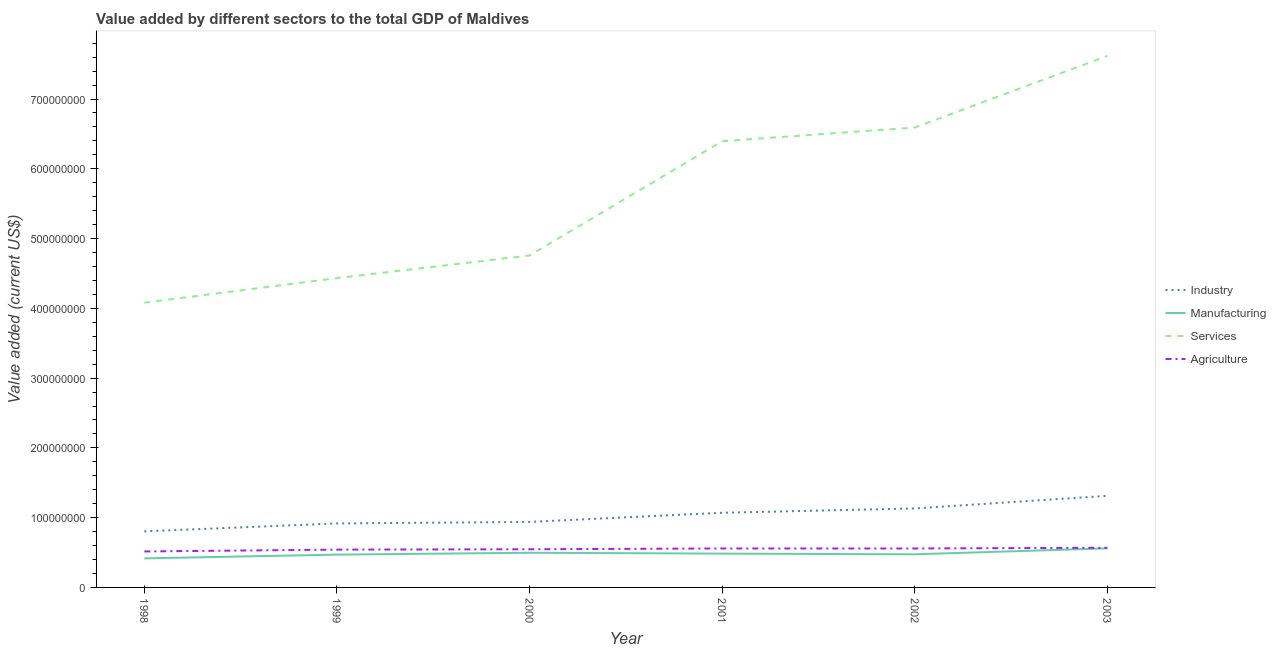Does the line corresponding to value added by agricultural sector intersect with the line corresponding to value added by services sector?
Offer a terse response. No. Is the number of lines equal to the number of legend labels?
Keep it short and to the point. Yes. What is the value added by services sector in 1999?
Keep it short and to the point. 4.43e+08. Across all years, what is the maximum value added by industrial sector?
Your answer should be compact. 1.31e+08. Across all years, what is the minimum value added by services sector?
Your answer should be compact. 4.08e+08. What is the total value added by industrial sector in the graph?
Your answer should be compact. 6.18e+08. What is the difference between the value added by manufacturing sector in 1999 and that in 2000?
Keep it short and to the point. -2.68e+06. What is the difference between the value added by industrial sector in 2001 and the value added by services sector in 1999?
Provide a short and direct response. -3.36e+08. What is the average value added by industrial sector per year?
Provide a short and direct response. 1.03e+08. In the year 2001, what is the difference between the value added by manufacturing sector and value added by agricultural sector?
Give a very brief answer. -7.42e+06. In how many years, is the value added by manufacturing sector greater than 40000000 US$?
Your answer should be compact. 6. What is the ratio of the value added by agricultural sector in 1999 to that in 2003?
Your answer should be very brief. 0.95. Is the difference between the value added by manufacturing sector in 2001 and 2002 greater than the difference between the value added by industrial sector in 2001 and 2002?
Offer a very short reply. Yes. What is the difference between the highest and the second highest value added by agricultural sector?
Your answer should be compact. 9.67e+05. What is the difference between the highest and the lowest value added by manufacturing sector?
Offer a terse response. 1.44e+07. Is it the case that in every year, the sum of the value added by industrial sector and value added by manufacturing sector is greater than the value added by services sector?
Provide a succinct answer. No. Is the value added by services sector strictly greater than the value added by manufacturing sector over the years?
Provide a short and direct response. Yes. Is the value added by agricultural sector strictly less than the value added by manufacturing sector over the years?
Offer a very short reply. No. How many lines are there?
Make the answer very short. 4. How many years are there in the graph?
Provide a succinct answer. 6. What is the difference between two consecutive major ticks on the Y-axis?
Give a very brief answer. 1.00e+08. Are the values on the major ticks of Y-axis written in scientific E-notation?
Provide a succinct answer. No. How are the legend labels stacked?
Offer a very short reply. Vertical. What is the title of the graph?
Give a very brief answer. Value added by different sectors to the total GDP of Maldives. Does "Other expenses" appear as one of the legend labels in the graph?
Make the answer very short. No. What is the label or title of the X-axis?
Provide a short and direct response. Year. What is the label or title of the Y-axis?
Give a very brief answer. Value added (current US$). What is the Value added (current US$) of Industry in 1998?
Provide a short and direct response. 8.04e+07. What is the Value added (current US$) in Manufacturing in 1998?
Your answer should be compact. 4.16e+07. What is the Value added (current US$) of Services in 1998?
Give a very brief answer. 4.08e+08. What is the Value added (current US$) of Agriculture in 1998?
Give a very brief answer. 5.16e+07. What is the Value added (current US$) of Industry in 1999?
Ensure brevity in your answer.  9.17e+07. What is the Value added (current US$) of Manufacturing in 1999?
Keep it short and to the point. 4.70e+07. What is the Value added (current US$) in Services in 1999?
Provide a succinct answer. 4.43e+08. What is the Value added (current US$) in Agriculture in 1999?
Keep it short and to the point. 5.42e+07. What is the Value added (current US$) in Industry in 2000?
Ensure brevity in your answer.  9.39e+07. What is the Value added (current US$) of Manufacturing in 2000?
Provide a short and direct response. 4.97e+07. What is the Value added (current US$) of Services in 2000?
Offer a very short reply. 4.76e+08. What is the Value added (current US$) of Agriculture in 2000?
Your response must be concise. 5.47e+07. What is the Value added (current US$) in Industry in 2001?
Offer a terse response. 1.07e+08. What is the Value added (current US$) of Manufacturing in 2001?
Make the answer very short. 4.84e+07. What is the Value added (current US$) in Services in 2001?
Ensure brevity in your answer.  6.40e+08. What is the Value added (current US$) of Agriculture in 2001?
Provide a short and direct response. 5.59e+07. What is the Value added (current US$) in Industry in 2002?
Keep it short and to the point. 1.13e+08. What is the Value added (current US$) in Manufacturing in 2002?
Offer a terse response. 4.75e+07. What is the Value added (current US$) in Services in 2002?
Give a very brief answer. 6.59e+08. What is the Value added (current US$) of Agriculture in 2002?
Your response must be concise. 5.58e+07. What is the Value added (current US$) of Industry in 2003?
Your answer should be compact. 1.31e+08. What is the Value added (current US$) in Manufacturing in 2003?
Provide a short and direct response. 5.60e+07. What is the Value added (current US$) of Services in 2003?
Give a very brief answer. 7.62e+08. What is the Value added (current US$) of Agriculture in 2003?
Keep it short and to the point. 5.68e+07. Across all years, what is the maximum Value added (current US$) in Industry?
Ensure brevity in your answer.  1.31e+08. Across all years, what is the maximum Value added (current US$) in Manufacturing?
Keep it short and to the point. 5.60e+07. Across all years, what is the maximum Value added (current US$) of Services?
Provide a short and direct response. 7.62e+08. Across all years, what is the maximum Value added (current US$) in Agriculture?
Keep it short and to the point. 5.68e+07. Across all years, what is the minimum Value added (current US$) of Industry?
Ensure brevity in your answer.  8.04e+07. Across all years, what is the minimum Value added (current US$) in Manufacturing?
Your answer should be very brief. 4.16e+07. Across all years, what is the minimum Value added (current US$) in Services?
Your response must be concise. 4.08e+08. Across all years, what is the minimum Value added (current US$) of Agriculture?
Ensure brevity in your answer.  5.16e+07. What is the total Value added (current US$) in Industry in the graph?
Keep it short and to the point. 6.18e+08. What is the total Value added (current US$) in Manufacturing in the graph?
Your answer should be compact. 2.90e+08. What is the total Value added (current US$) in Services in the graph?
Make the answer very short. 3.39e+09. What is the total Value added (current US$) of Agriculture in the graph?
Give a very brief answer. 3.29e+08. What is the difference between the Value added (current US$) of Industry in 1998 and that in 1999?
Your response must be concise. -1.13e+07. What is the difference between the Value added (current US$) in Manufacturing in 1998 and that in 1999?
Provide a short and direct response. -5.39e+06. What is the difference between the Value added (current US$) of Services in 1998 and that in 1999?
Keep it short and to the point. -3.52e+07. What is the difference between the Value added (current US$) in Agriculture in 1998 and that in 1999?
Your answer should be very brief. -2.61e+06. What is the difference between the Value added (current US$) in Industry in 1998 and that in 2000?
Your answer should be compact. -1.35e+07. What is the difference between the Value added (current US$) of Manufacturing in 1998 and that in 2000?
Provide a short and direct response. -8.07e+06. What is the difference between the Value added (current US$) of Services in 1998 and that in 2000?
Keep it short and to the point. -6.76e+07. What is the difference between the Value added (current US$) in Agriculture in 1998 and that in 2000?
Your answer should be very brief. -3.13e+06. What is the difference between the Value added (current US$) of Industry in 1998 and that in 2001?
Give a very brief answer. -2.66e+07. What is the difference between the Value added (current US$) in Manufacturing in 1998 and that in 2001?
Give a very brief answer. -6.81e+06. What is the difference between the Value added (current US$) of Services in 1998 and that in 2001?
Your answer should be very brief. -2.31e+08. What is the difference between the Value added (current US$) in Agriculture in 1998 and that in 2001?
Ensure brevity in your answer.  -4.29e+06. What is the difference between the Value added (current US$) of Industry in 1998 and that in 2002?
Your response must be concise. -3.28e+07. What is the difference between the Value added (current US$) in Manufacturing in 1998 and that in 2002?
Your response must be concise. -5.86e+06. What is the difference between the Value added (current US$) of Services in 1998 and that in 2002?
Give a very brief answer. -2.51e+08. What is the difference between the Value added (current US$) of Agriculture in 1998 and that in 2002?
Your answer should be very brief. -4.26e+06. What is the difference between the Value added (current US$) in Industry in 1998 and that in 2003?
Offer a terse response. -5.09e+07. What is the difference between the Value added (current US$) in Manufacturing in 1998 and that in 2003?
Give a very brief answer. -1.44e+07. What is the difference between the Value added (current US$) of Services in 1998 and that in 2003?
Give a very brief answer. -3.54e+08. What is the difference between the Value added (current US$) in Agriculture in 1998 and that in 2003?
Ensure brevity in your answer.  -5.26e+06. What is the difference between the Value added (current US$) in Industry in 1999 and that in 2000?
Make the answer very short. -2.16e+06. What is the difference between the Value added (current US$) in Manufacturing in 1999 and that in 2000?
Provide a succinct answer. -2.68e+06. What is the difference between the Value added (current US$) of Services in 1999 and that in 2000?
Your answer should be very brief. -3.24e+07. What is the difference between the Value added (current US$) of Agriculture in 1999 and that in 2000?
Provide a succinct answer. -5.16e+05. What is the difference between the Value added (current US$) of Industry in 1999 and that in 2001?
Offer a terse response. -1.53e+07. What is the difference between the Value added (current US$) of Manufacturing in 1999 and that in 2001?
Your answer should be compact. -1.42e+06. What is the difference between the Value added (current US$) in Services in 1999 and that in 2001?
Keep it short and to the point. -1.96e+08. What is the difference between the Value added (current US$) of Agriculture in 1999 and that in 2001?
Provide a short and direct response. -1.68e+06. What is the difference between the Value added (current US$) in Industry in 1999 and that in 2002?
Your answer should be very brief. -2.15e+07. What is the difference between the Value added (current US$) in Manufacturing in 1999 and that in 2002?
Make the answer very short. -4.71e+05. What is the difference between the Value added (current US$) of Services in 1999 and that in 2002?
Your response must be concise. -2.16e+08. What is the difference between the Value added (current US$) of Agriculture in 1999 and that in 2002?
Provide a succinct answer. -1.65e+06. What is the difference between the Value added (current US$) of Industry in 1999 and that in 2003?
Your answer should be compact. -3.96e+07. What is the difference between the Value added (current US$) of Manufacturing in 1999 and that in 2003?
Your answer should be compact. -8.97e+06. What is the difference between the Value added (current US$) of Services in 1999 and that in 2003?
Give a very brief answer. -3.18e+08. What is the difference between the Value added (current US$) in Agriculture in 1999 and that in 2003?
Keep it short and to the point. -2.65e+06. What is the difference between the Value added (current US$) in Industry in 2000 and that in 2001?
Provide a succinct answer. -1.31e+07. What is the difference between the Value added (current US$) of Manufacturing in 2000 and that in 2001?
Keep it short and to the point. 1.26e+06. What is the difference between the Value added (current US$) in Services in 2000 and that in 2001?
Make the answer very short. -1.64e+08. What is the difference between the Value added (current US$) in Agriculture in 2000 and that in 2001?
Offer a very short reply. -1.16e+06. What is the difference between the Value added (current US$) in Industry in 2000 and that in 2002?
Give a very brief answer. -1.93e+07. What is the difference between the Value added (current US$) of Manufacturing in 2000 and that in 2002?
Make the answer very short. 2.21e+06. What is the difference between the Value added (current US$) of Services in 2000 and that in 2002?
Make the answer very short. -1.83e+08. What is the difference between the Value added (current US$) in Agriculture in 2000 and that in 2002?
Your answer should be compact. -1.14e+06. What is the difference between the Value added (current US$) in Industry in 2000 and that in 2003?
Offer a terse response. -3.74e+07. What is the difference between the Value added (current US$) of Manufacturing in 2000 and that in 2003?
Your answer should be compact. -6.29e+06. What is the difference between the Value added (current US$) of Services in 2000 and that in 2003?
Provide a short and direct response. -2.86e+08. What is the difference between the Value added (current US$) of Agriculture in 2000 and that in 2003?
Offer a very short reply. -2.13e+06. What is the difference between the Value added (current US$) of Industry in 2001 and that in 2002?
Your answer should be very brief. -6.17e+06. What is the difference between the Value added (current US$) of Manufacturing in 2001 and that in 2002?
Provide a short and direct response. 9.48e+05. What is the difference between the Value added (current US$) of Services in 2001 and that in 2002?
Keep it short and to the point. -1.97e+07. What is the difference between the Value added (current US$) in Agriculture in 2001 and that in 2002?
Ensure brevity in your answer.  2.72e+04. What is the difference between the Value added (current US$) in Industry in 2001 and that in 2003?
Provide a succinct answer. -2.43e+07. What is the difference between the Value added (current US$) of Manufacturing in 2001 and that in 2003?
Your response must be concise. -7.55e+06. What is the difference between the Value added (current US$) in Services in 2001 and that in 2003?
Ensure brevity in your answer.  -1.22e+08. What is the difference between the Value added (current US$) in Agriculture in 2001 and that in 2003?
Keep it short and to the point. -9.67e+05. What is the difference between the Value added (current US$) in Industry in 2002 and that in 2003?
Offer a very short reply. -1.81e+07. What is the difference between the Value added (current US$) in Manufacturing in 2002 and that in 2003?
Your response must be concise. -8.50e+06. What is the difference between the Value added (current US$) in Services in 2002 and that in 2003?
Provide a short and direct response. -1.03e+08. What is the difference between the Value added (current US$) in Agriculture in 2002 and that in 2003?
Ensure brevity in your answer.  -9.95e+05. What is the difference between the Value added (current US$) of Industry in 1998 and the Value added (current US$) of Manufacturing in 1999?
Keep it short and to the point. 3.34e+07. What is the difference between the Value added (current US$) in Industry in 1998 and the Value added (current US$) in Services in 1999?
Make the answer very short. -3.63e+08. What is the difference between the Value added (current US$) of Industry in 1998 and the Value added (current US$) of Agriculture in 1999?
Keep it short and to the point. 2.62e+07. What is the difference between the Value added (current US$) in Manufacturing in 1998 and the Value added (current US$) in Services in 1999?
Offer a terse response. -4.02e+08. What is the difference between the Value added (current US$) in Manufacturing in 1998 and the Value added (current US$) in Agriculture in 1999?
Keep it short and to the point. -1.25e+07. What is the difference between the Value added (current US$) in Services in 1998 and the Value added (current US$) in Agriculture in 1999?
Keep it short and to the point. 3.54e+08. What is the difference between the Value added (current US$) in Industry in 1998 and the Value added (current US$) in Manufacturing in 2000?
Keep it short and to the point. 3.07e+07. What is the difference between the Value added (current US$) in Industry in 1998 and the Value added (current US$) in Services in 2000?
Make the answer very short. -3.95e+08. What is the difference between the Value added (current US$) in Industry in 1998 and the Value added (current US$) in Agriculture in 2000?
Your answer should be compact. 2.57e+07. What is the difference between the Value added (current US$) in Manufacturing in 1998 and the Value added (current US$) in Services in 2000?
Your answer should be very brief. -4.34e+08. What is the difference between the Value added (current US$) in Manufacturing in 1998 and the Value added (current US$) in Agriculture in 2000?
Your answer should be very brief. -1.31e+07. What is the difference between the Value added (current US$) of Services in 1998 and the Value added (current US$) of Agriculture in 2000?
Provide a succinct answer. 3.53e+08. What is the difference between the Value added (current US$) in Industry in 1998 and the Value added (current US$) in Manufacturing in 2001?
Make the answer very short. 3.19e+07. What is the difference between the Value added (current US$) of Industry in 1998 and the Value added (current US$) of Services in 2001?
Keep it short and to the point. -5.59e+08. What is the difference between the Value added (current US$) of Industry in 1998 and the Value added (current US$) of Agriculture in 2001?
Provide a short and direct response. 2.45e+07. What is the difference between the Value added (current US$) in Manufacturing in 1998 and the Value added (current US$) in Services in 2001?
Offer a terse response. -5.98e+08. What is the difference between the Value added (current US$) of Manufacturing in 1998 and the Value added (current US$) of Agriculture in 2001?
Provide a short and direct response. -1.42e+07. What is the difference between the Value added (current US$) of Services in 1998 and the Value added (current US$) of Agriculture in 2001?
Ensure brevity in your answer.  3.52e+08. What is the difference between the Value added (current US$) of Industry in 1998 and the Value added (current US$) of Manufacturing in 2002?
Your answer should be compact. 3.29e+07. What is the difference between the Value added (current US$) of Industry in 1998 and the Value added (current US$) of Services in 2002?
Make the answer very short. -5.79e+08. What is the difference between the Value added (current US$) of Industry in 1998 and the Value added (current US$) of Agriculture in 2002?
Ensure brevity in your answer.  2.46e+07. What is the difference between the Value added (current US$) in Manufacturing in 1998 and the Value added (current US$) in Services in 2002?
Ensure brevity in your answer.  -6.18e+08. What is the difference between the Value added (current US$) in Manufacturing in 1998 and the Value added (current US$) in Agriculture in 2002?
Offer a terse response. -1.42e+07. What is the difference between the Value added (current US$) in Services in 1998 and the Value added (current US$) in Agriculture in 2002?
Offer a terse response. 3.52e+08. What is the difference between the Value added (current US$) in Industry in 1998 and the Value added (current US$) in Manufacturing in 2003?
Provide a short and direct response. 2.44e+07. What is the difference between the Value added (current US$) in Industry in 1998 and the Value added (current US$) in Services in 2003?
Provide a short and direct response. -6.81e+08. What is the difference between the Value added (current US$) of Industry in 1998 and the Value added (current US$) of Agriculture in 2003?
Your answer should be very brief. 2.36e+07. What is the difference between the Value added (current US$) of Manufacturing in 1998 and the Value added (current US$) of Services in 2003?
Make the answer very short. -7.20e+08. What is the difference between the Value added (current US$) in Manufacturing in 1998 and the Value added (current US$) in Agriculture in 2003?
Provide a short and direct response. -1.52e+07. What is the difference between the Value added (current US$) in Services in 1998 and the Value added (current US$) in Agriculture in 2003?
Provide a short and direct response. 3.51e+08. What is the difference between the Value added (current US$) of Industry in 1999 and the Value added (current US$) of Manufacturing in 2000?
Offer a terse response. 4.20e+07. What is the difference between the Value added (current US$) in Industry in 1999 and the Value added (current US$) in Services in 2000?
Offer a very short reply. -3.84e+08. What is the difference between the Value added (current US$) of Industry in 1999 and the Value added (current US$) of Agriculture in 2000?
Your answer should be very brief. 3.70e+07. What is the difference between the Value added (current US$) of Manufacturing in 1999 and the Value added (current US$) of Services in 2000?
Your answer should be very brief. -4.29e+08. What is the difference between the Value added (current US$) in Manufacturing in 1999 and the Value added (current US$) in Agriculture in 2000?
Make the answer very short. -7.68e+06. What is the difference between the Value added (current US$) in Services in 1999 and the Value added (current US$) in Agriculture in 2000?
Keep it short and to the point. 3.89e+08. What is the difference between the Value added (current US$) of Industry in 1999 and the Value added (current US$) of Manufacturing in 2001?
Your answer should be compact. 4.33e+07. What is the difference between the Value added (current US$) of Industry in 1999 and the Value added (current US$) of Services in 2001?
Your answer should be very brief. -5.48e+08. What is the difference between the Value added (current US$) of Industry in 1999 and the Value added (current US$) of Agriculture in 2001?
Your answer should be compact. 3.59e+07. What is the difference between the Value added (current US$) in Manufacturing in 1999 and the Value added (current US$) in Services in 2001?
Offer a terse response. -5.93e+08. What is the difference between the Value added (current US$) of Manufacturing in 1999 and the Value added (current US$) of Agriculture in 2001?
Your response must be concise. -8.84e+06. What is the difference between the Value added (current US$) in Services in 1999 and the Value added (current US$) in Agriculture in 2001?
Ensure brevity in your answer.  3.87e+08. What is the difference between the Value added (current US$) in Industry in 1999 and the Value added (current US$) in Manufacturing in 2002?
Offer a very short reply. 4.42e+07. What is the difference between the Value added (current US$) in Industry in 1999 and the Value added (current US$) in Services in 2002?
Your answer should be compact. -5.67e+08. What is the difference between the Value added (current US$) of Industry in 1999 and the Value added (current US$) of Agriculture in 2002?
Give a very brief answer. 3.59e+07. What is the difference between the Value added (current US$) in Manufacturing in 1999 and the Value added (current US$) in Services in 2002?
Your response must be concise. -6.12e+08. What is the difference between the Value added (current US$) of Manufacturing in 1999 and the Value added (current US$) of Agriculture in 2002?
Provide a succinct answer. -8.81e+06. What is the difference between the Value added (current US$) of Services in 1999 and the Value added (current US$) of Agriculture in 2002?
Provide a short and direct response. 3.88e+08. What is the difference between the Value added (current US$) of Industry in 1999 and the Value added (current US$) of Manufacturing in 2003?
Provide a succinct answer. 3.57e+07. What is the difference between the Value added (current US$) in Industry in 1999 and the Value added (current US$) in Services in 2003?
Your answer should be very brief. -6.70e+08. What is the difference between the Value added (current US$) of Industry in 1999 and the Value added (current US$) of Agriculture in 2003?
Provide a short and direct response. 3.49e+07. What is the difference between the Value added (current US$) in Manufacturing in 1999 and the Value added (current US$) in Services in 2003?
Provide a short and direct response. -7.15e+08. What is the difference between the Value added (current US$) in Manufacturing in 1999 and the Value added (current US$) in Agriculture in 2003?
Your answer should be very brief. -9.81e+06. What is the difference between the Value added (current US$) of Services in 1999 and the Value added (current US$) of Agriculture in 2003?
Offer a very short reply. 3.87e+08. What is the difference between the Value added (current US$) of Industry in 2000 and the Value added (current US$) of Manufacturing in 2001?
Your response must be concise. 4.54e+07. What is the difference between the Value added (current US$) of Industry in 2000 and the Value added (current US$) of Services in 2001?
Offer a terse response. -5.46e+08. What is the difference between the Value added (current US$) of Industry in 2000 and the Value added (current US$) of Agriculture in 2001?
Offer a very short reply. 3.80e+07. What is the difference between the Value added (current US$) of Manufacturing in 2000 and the Value added (current US$) of Services in 2001?
Ensure brevity in your answer.  -5.90e+08. What is the difference between the Value added (current US$) in Manufacturing in 2000 and the Value added (current US$) in Agriculture in 2001?
Offer a very short reply. -6.16e+06. What is the difference between the Value added (current US$) of Services in 2000 and the Value added (current US$) of Agriculture in 2001?
Offer a terse response. 4.20e+08. What is the difference between the Value added (current US$) of Industry in 2000 and the Value added (current US$) of Manufacturing in 2002?
Provide a succinct answer. 4.64e+07. What is the difference between the Value added (current US$) in Industry in 2000 and the Value added (current US$) in Services in 2002?
Your response must be concise. -5.65e+08. What is the difference between the Value added (current US$) of Industry in 2000 and the Value added (current US$) of Agriculture in 2002?
Ensure brevity in your answer.  3.80e+07. What is the difference between the Value added (current US$) in Manufacturing in 2000 and the Value added (current US$) in Services in 2002?
Give a very brief answer. -6.10e+08. What is the difference between the Value added (current US$) of Manufacturing in 2000 and the Value added (current US$) of Agriculture in 2002?
Your answer should be very brief. -6.13e+06. What is the difference between the Value added (current US$) in Services in 2000 and the Value added (current US$) in Agriculture in 2002?
Your answer should be compact. 4.20e+08. What is the difference between the Value added (current US$) in Industry in 2000 and the Value added (current US$) in Manufacturing in 2003?
Make the answer very short. 3.79e+07. What is the difference between the Value added (current US$) of Industry in 2000 and the Value added (current US$) of Services in 2003?
Your answer should be compact. -6.68e+08. What is the difference between the Value added (current US$) of Industry in 2000 and the Value added (current US$) of Agriculture in 2003?
Provide a short and direct response. 3.71e+07. What is the difference between the Value added (current US$) of Manufacturing in 2000 and the Value added (current US$) of Services in 2003?
Give a very brief answer. -7.12e+08. What is the difference between the Value added (current US$) in Manufacturing in 2000 and the Value added (current US$) in Agriculture in 2003?
Your answer should be very brief. -7.13e+06. What is the difference between the Value added (current US$) of Services in 2000 and the Value added (current US$) of Agriculture in 2003?
Your answer should be compact. 4.19e+08. What is the difference between the Value added (current US$) of Industry in 2001 and the Value added (current US$) of Manufacturing in 2002?
Offer a very short reply. 5.95e+07. What is the difference between the Value added (current US$) in Industry in 2001 and the Value added (current US$) in Services in 2002?
Keep it short and to the point. -5.52e+08. What is the difference between the Value added (current US$) in Industry in 2001 and the Value added (current US$) in Agriculture in 2002?
Offer a terse response. 5.12e+07. What is the difference between the Value added (current US$) of Manufacturing in 2001 and the Value added (current US$) of Services in 2002?
Make the answer very short. -6.11e+08. What is the difference between the Value added (current US$) of Manufacturing in 2001 and the Value added (current US$) of Agriculture in 2002?
Offer a terse response. -7.39e+06. What is the difference between the Value added (current US$) of Services in 2001 and the Value added (current US$) of Agriculture in 2002?
Your answer should be compact. 5.84e+08. What is the difference between the Value added (current US$) in Industry in 2001 and the Value added (current US$) in Manufacturing in 2003?
Your answer should be compact. 5.10e+07. What is the difference between the Value added (current US$) in Industry in 2001 and the Value added (current US$) in Services in 2003?
Your response must be concise. -6.55e+08. What is the difference between the Value added (current US$) in Industry in 2001 and the Value added (current US$) in Agriculture in 2003?
Your answer should be very brief. 5.02e+07. What is the difference between the Value added (current US$) of Manufacturing in 2001 and the Value added (current US$) of Services in 2003?
Provide a short and direct response. -7.13e+08. What is the difference between the Value added (current US$) in Manufacturing in 2001 and the Value added (current US$) in Agriculture in 2003?
Your answer should be very brief. -8.39e+06. What is the difference between the Value added (current US$) of Services in 2001 and the Value added (current US$) of Agriculture in 2003?
Provide a succinct answer. 5.83e+08. What is the difference between the Value added (current US$) in Industry in 2002 and the Value added (current US$) in Manufacturing in 2003?
Ensure brevity in your answer.  5.72e+07. What is the difference between the Value added (current US$) in Industry in 2002 and the Value added (current US$) in Services in 2003?
Your response must be concise. -6.49e+08. What is the difference between the Value added (current US$) of Industry in 2002 and the Value added (current US$) of Agriculture in 2003?
Provide a succinct answer. 5.64e+07. What is the difference between the Value added (current US$) of Manufacturing in 2002 and the Value added (current US$) of Services in 2003?
Your answer should be compact. -7.14e+08. What is the difference between the Value added (current US$) in Manufacturing in 2002 and the Value added (current US$) in Agriculture in 2003?
Offer a very short reply. -9.34e+06. What is the difference between the Value added (current US$) in Services in 2002 and the Value added (current US$) in Agriculture in 2003?
Your answer should be very brief. 6.02e+08. What is the average Value added (current US$) of Industry per year?
Make the answer very short. 1.03e+08. What is the average Value added (current US$) in Manufacturing per year?
Provide a succinct answer. 4.84e+07. What is the average Value added (current US$) of Services per year?
Provide a short and direct response. 5.65e+08. What is the average Value added (current US$) in Agriculture per year?
Your answer should be very brief. 5.48e+07. In the year 1998, what is the difference between the Value added (current US$) in Industry and Value added (current US$) in Manufacturing?
Provide a short and direct response. 3.88e+07. In the year 1998, what is the difference between the Value added (current US$) in Industry and Value added (current US$) in Services?
Offer a terse response. -3.28e+08. In the year 1998, what is the difference between the Value added (current US$) of Industry and Value added (current US$) of Agriculture?
Your answer should be compact. 2.88e+07. In the year 1998, what is the difference between the Value added (current US$) of Manufacturing and Value added (current US$) of Services?
Make the answer very short. -3.67e+08. In the year 1998, what is the difference between the Value added (current US$) in Manufacturing and Value added (current US$) in Agriculture?
Offer a very short reply. -9.94e+06. In the year 1998, what is the difference between the Value added (current US$) in Services and Value added (current US$) in Agriculture?
Your answer should be very brief. 3.57e+08. In the year 1999, what is the difference between the Value added (current US$) in Industry and Value added (current US$) in Manufacturing?
Ensure brevity in your answer.  4.47e+07. In the year 1999, what is the difference between the Value added (current US$) of Industry and Value added (current US$) of Services?
Provide a succinct answer. -3.52e+08. In the year 1999, what is the difference between the Value added (current US$) of Industry and Value added (current US$) of Agriculture?
Your answer should be very brief. 3.75e+07. In the year 1999, what is the difference between the Value added (current US$) of Manufacturing and Value added (current US$) of Services?
Ensure brevity in your answer.  -3.96e+08. In the year 1999, what is the difference between the Value added (current US$) of Manufacturing and Value added (current US$) of Agriculture?
Keep it short and to the point. -7.16e+06. In the year 1999, what is the difference between the Value added (current US$) in Services and Value added (current US$) in Agriculture?
Ensure brevity in your answer.  3.89e+08. In the year 2000, what is the difference between the Value added (current US$) of Industry and Value added (current US$) of Manufacturing?
Make the answer very short. 4.42e+07. In the year 2000, what is the difference between the Value added (current US$) in Industry and Value added (current US$) in Services?
Provide a short and direct response. -3.82e+08. In the year 2000, what is the difference between the Value added (current US$) in Industry and Value added (current US$) in Agriculture?
Offer a terse response. 3.92e+07. In the year 2000, what is the difference between the Value added (current US$) in Manufacturing and Value added (current US$) in Services?
Your answer should be compact. -4.26e+08. In the year 2000, what is the difference between the Value added (current US$) in Manufacturing and Value added (current US$) in Agriculture?
Your answer should be compact. -5.00e+06. In the year 2000, what is the difference between the Value added (current US$) of Services and Value added (current US$) of Agriculture?
Your answer should be compact. 4.21e+08. In the year 2001, what is the difference between the Value added (current US$) in Industry and Value added (current US$) in Manufacturing?
Provide a succinct answer. 5.86e+07. In the year 2001, what is the difference between the Value added (current US$) of Industry and Value added (current US$) of Services?
Give a very brief answer. -5.33e+08. In the year 2001, what is the difference between the Value added (current US$) in Industry and Value added (current US$) in Agriculture?
Offer a terse response. 5.12e+07. In the year 2001, what is the difference between the Value added (current US$) of Manufacturing and Value added (current US$) of Services?
Keep it short and to the point. -5.91e+08. In the year 2001, what is the difference between the Value added (current US$) of Manufacturing and Value added (current US$) of Agriculture?
Your answer should be very brief. -7.42e+06. In the year 2001, what is the difference between the Value added (current US$) of Services and Value added (current US$) of Agriculture?
Offer a very short reply. 5.84e+08. In the year 2002, what is the difference between the Value added (current US$) in Industry and Value added (current US$) in Manufacturing?
Your answer should be very brief. 6.57e+07. In the year 2002, what is the difference between the Value added (current US$) in Industry and Value added (current US$) in Services?
Provide a succinct answer. -5.46e+08. In the year 2002, what is the difference between the Value added (current US$) of Industry and Value added (current US$) of Agriculture?
Your answer should be compact. 5.74e+07. In the year 2002, what is the difference between the Value added (current US$) in Manufacturing and Value added (current US$) in Services?
Your answer should be very brief. -6.12e+08. In the year 2002, what is the difference between the Value added (current US$) of Manufacturing and Value added (current US$) of Agriculture?
Provide a short and direct response. -8.34e+06. In the year 2002, what is the difference between the Value added (current US$) of Services and Value added (current US$) of Agriculture?
Provide a short and direct response. 6.03e+08. In the year 2003, what is the difference between the Value added (current US$) of Industry and Value added (current US$) of Manufacturing?
Keep it short and to the point. 7.53e+07. In the year 2003, what is the difference between the Value added (current US$) in Industry and Value added (current US$) in Services?
Give a very brief answer. -6.30e+08. In the year 2003, what is the difference between the Value added (current US$) in Industry and Value added (current US$) in Agriculture?
Ensure brevity in your answer.  7.45e+07. In the year 2003, what is the difference between the Value added (current US$) in Manufacturing and Value added (current US$) in Services?
Give a very brief answer. -7.06e+08. In the year 2003, what is the difference between the Value added (current US$) of Manufacturing and Value added (current US$) of Agriculture?
Your answer should be compact. -8.41e+05. In the year 2003, what is the difference between the Value added (current US$) of Services and Value added (current US$) of Agriculture?
Keep it short and to the point. 7.05e+08. What is the ratio of the Value added (current US$) of Industry in 1998 to that in 1999?
Make the answer very short. 0.88. What is the ratio of the Value added (current US$) of Manufacturing in 1998 to that in 1999?
Ensure brevity in your answer.  0.89. What is the ratio of the Value added (current US$) of Services in 1998 to that in 1999?
Ensure brevity in your answer.  0.92. What is the ratio of the Value added (current US$) of Agriculture in 1998 to that in 1999?
Offer a very short reply. 0.95. What is the ratio of the Value added (current US$) of Industry in 1998 to that in 2000?
Your answer should be very brief. 0.86. What is the ratio of the Value added (current US$) in Manufacturing in 1998 to that in 2000?
Your answer should be compact. 0.84. What is the ratio of the Value added (current US$) of Services in 1998 to that in 2000?
Your answer should be very brief. 0.86. What is the ratio of the Value added (current US$) of Agriculture in 1998 to that in 2000?
Provide a short and direct response. 0.94. What is the ratio of the Value added (current US$) of Industry in 1998 to that in 2001?
Your answer should be compact. 0.75. What is the ratio of the Value added (current US$) in Manufacturing in 1998 to that in 2001?
Your answer should be compact. 0.86. What is the ratio of the Value added (current US$) of Services in 1998 to that in 2001?
Provide a succinct answer. 0.64. What is the ratio of the Value added (current US$) of Agriculture in 1998 to that in 2001?
Your answer should be compact. 0.92. What is the ratio of the Value added (current US$) of Industry in 1998 to that in 2002?
Your response must be concise. 0.71. What is the ratio of the Value added (current US$) of Manufacturing in 1998 to that in 2002?
Your answer should be compact. 0.88. What is the ratio of the Value added (current US$) in Services in 1998 to that in 2002?
Keep it short and to the point. 0.62. What is the ratio of the Value added (current US$) in Agriculture in 1998 to that in 2002?
Offer a very short reply. 0.92. What is the ratio of the Value added (current US$) of Industry in 1998 to that in 2003?
Your response must be concise. 0.61. What is the ratio of the Value added (current US$) of Manufacturing in 1998 to that in 2003?
Ensure brevity in your answer.  0.74. What is the ratio of the Value added (current US$) of Services in 1998 to that in 2003?
Your answer should be very brief. 0.54. What is the ratio of the Value added (current US$) of Agriculture in 1998 to that in 2003?
Offer a very short reply. 0.91. What is the ratio of the Value added (current US$) of Industry in 1999 to that in 2000?
Provide a succinct answer. 0.98. What is the ratio of the Value added (current US$) in Manufacturing in 1999 to that in 2000?
Offer a very short reply. 0.95. What is the ratio of the Value added (current US$) in Services in 1999 to that in 2000?
Ensure brevity in your answer.  0.93. What is the ratio of the Value added (current US$) in Agriculture in 1999 to that in 2000?
Provide a short and direct response. 0.99. What is the ratio of the Value added (current US$) in Industry in 1999 to that in 2001?
Provide a succinct answer. 0.86. What is the ratio of the Value added (current US$) of Manufacturing in 1999 to that in 2001?
Keep it short and to the point. 0.97. What is the ratio of the Value added (current US$) of Services in 1999 to that in 2001?
Make the answer very short. 0.69. What is the ratio of the Value added (current US$) in Agriculture in 1999 to that in 2001?
Ensure brevity in your answer.  0.97. What is the ratio of the Value added (current US$) of Industry in 1999 to that in 2002?
Your answer should be compact. 0.81. What is the ratio of the Value added (current US$) in Services in 1999 to that in 2002?
Provide a short and direct response. 0.67. What is the ratio of the Value added (current US$) of Agriculture in 1999 to that in 2002?
Make the answer very short. 0.97. What is the ratio of the Value added (current US$) in Industry in 1999 to that in 2003?
Offer a very short reply. 0.7. What is the ratio of the Value added (current US$) in Manufacturing in 1999 to that in 2003?
Your response must be concise. 0.84. What is the ratio of the Value added (current US$) in Services in 1999 to that in 2003?
Give a very brief answer. 0.58. What is the ratio of the Value added (current US$) of Agriculture in 1999 to that in 2003?
Offer a very short reply. 0.95. What is the ratio of the Value added (current US$) of Industry in 2000 to that in 2001?
Provide a short and direct response. 0.88. What is the ratio of the Value added (current US$) in Services in 2000 to that in 2001?
Your answer should be very brief. 0.74. What is the ratio of the Value added (current US$) in Agriculture in 2000 to that in 2001?
Provide a succinct answer. 0.98. What is the ratio of the Value added (current US$) in Industry in 2000 to that in 2002?
Offer a very short reply. 0.83. What is the ratio of the Value added (current US$) of Manufacturing in 2000 to that in 2002?
Keep it short and to the point. 1.05. What is the ratio of the Value added (current US$) of Services in 2000 to that in 2002?
Offer a terse response. 0.72. What is the ratio of the Value added (current US$) in Agriculture in 2000 to that in 2002?
Ensure brevity in your answer.  0.98. What is the ratio of the Value added (current US$) of Industry in 2000 to that in 2003?
Your response must be concise. 0.71. What is the ratio of the Value added (current US$) of Manufacturing in 2000 to that in 2003?
Provide a short and direct response. 0.89. What is the ratio of the Value added (current US$) in Services in 2000 to that in 2003?
Offer a terse response. 0.62. What is the ratio of the Value added (current US$) of Agriculture in 2000 to that in 2003?
Keep it short and to the point. 0.96. What is the ratio of the Value added (current US$) of Industry in 2001 to that in 2002?
Make the answer very short. 0.95. What is the ratio of the Value added (current US$) of Services in 2001 to that in 2002?
Offer a terse response. 0.97. What is the ratio of the Value added (current US$) in Industry in 2001 to that in 2003?
Your answer should be compact. 0.82. What is the ratio of the Value added (current US$) of Manufacturing in 2001 to that in 2003?
Your answer should be very brief. 0.87. What is the ratio of the Value added (current US$) in Services in 2001 to that in 2003?
Offer a very short reply. 0.84. What is the ratio of the Value added (current US$) in Agriculture in 2001 to that in 2003?
Give a very brief answer. 0.98. What is the ratio of the Value added (current US$) in Industry in 2002 to that in 2003?
Your answer should be compact. 0.86. What is the ratio of the Value added (current US$) in Manufacturing in 2002 to that in 2003?
Offer a terse response. 0.85. What is the ratio of the Value added (current US$) of Services in 2002 to that in 2003?
Make the answer very short. 0.87. What is the ratio of the Value added (current US$) in Agriculture in 2002 to that in 2003?
Provide a succinct answer. 0.98. What is the difference between the highest and the second highest Value added (current US$) in Industry?
Offer a very short reply. 1.81e+07. What is the difference between the highest and the second highest Value added (current US$) of Manufacturing?
Your answer should be very brief. 6.29e+06. What is the difference between the highest and the second highest Value added (current US$) of Services?
Keep it short and to the point. 1.03e+08. What is the difference between the highest and the second highest Value added (current US$) in Agriculture?
Provide a succinct answer. 9.67e+05. What is the difference between the highest and the lowest Value added (current US$) in Industry?
Make the answer very short. 5.09e+07. What is the difference between the highest and the lowest Value added (current US$) in Manufacturing?
Make the answer very short. 1.44e+07. What is the difference between the highest and the lowest Value added (current US$) of Services?
Provide a short and direct response. 3.54e+08. What is the difference between the highest and the lowest Value added (current US$) of Agriculture?
Provide a short and direct response. 5.26e+06. 